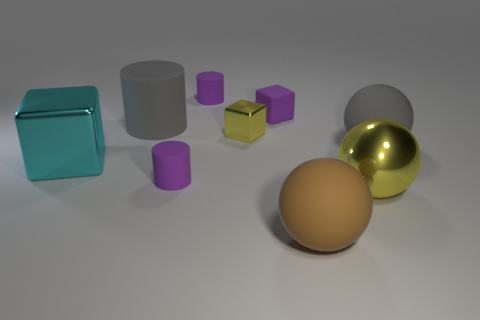What number of other objects are there of the same color as the tiny matte cube?
Provide a short and direct response. 2. There is a cube that is the same color as the large shiny ball; what material is it?
Provide a succinct answer. Metal. What is the color of the large sphere to the right of the yellow object in front of the rubber cylinder in front of the big cyan shiny block?
Offer a terse response. Gray. How many big objects are shiny cubes or blue metallic balls?
Your answer should be compact. 1. Are there the same number of brown rubber spheres that are behind the metallic sphere and big cyan metallic things?
Ensure brevity in your answer.  No. There is a large cylinder; are there any cyan objects right of it?
Your response must be concise. No. How many matte objects are brown things or purple cubes?
Offer a very short reply. 2. How many tiny rubber things are behind the big cyan metallic thing?
Your answer should be compact. 2. Are there any brown matte things of the same size as the purple block?
Ensure brevity in your answer.  No. Is there a large block of the same color as the tiny metal block?
Provide a short and direct response. No. 